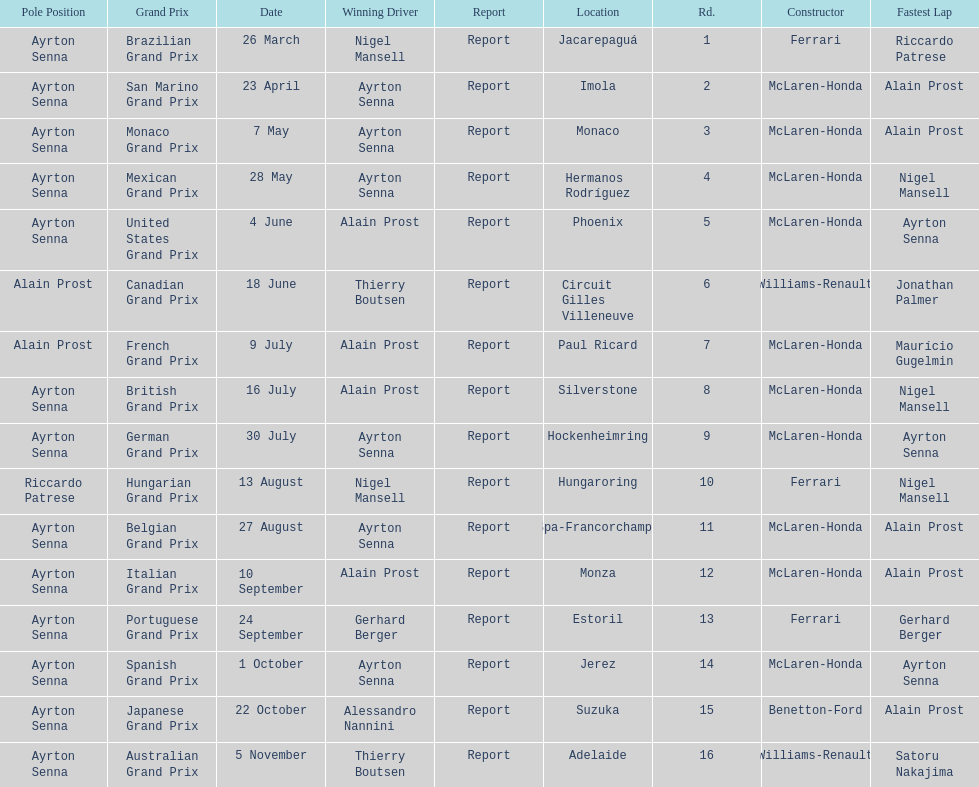What was the only grand prix to be won by benneton-ford? Japanese Grand Prix. 